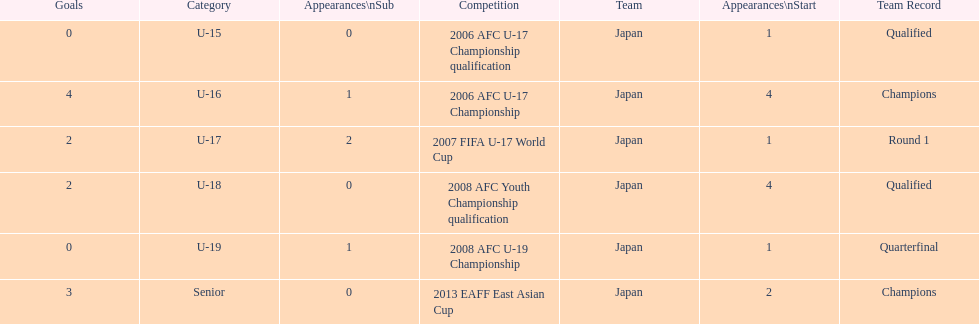In which two competitions did japan lack goals? 2006 AFC U-17 Championship qualification, 2008 AFC U-19 Championship. 